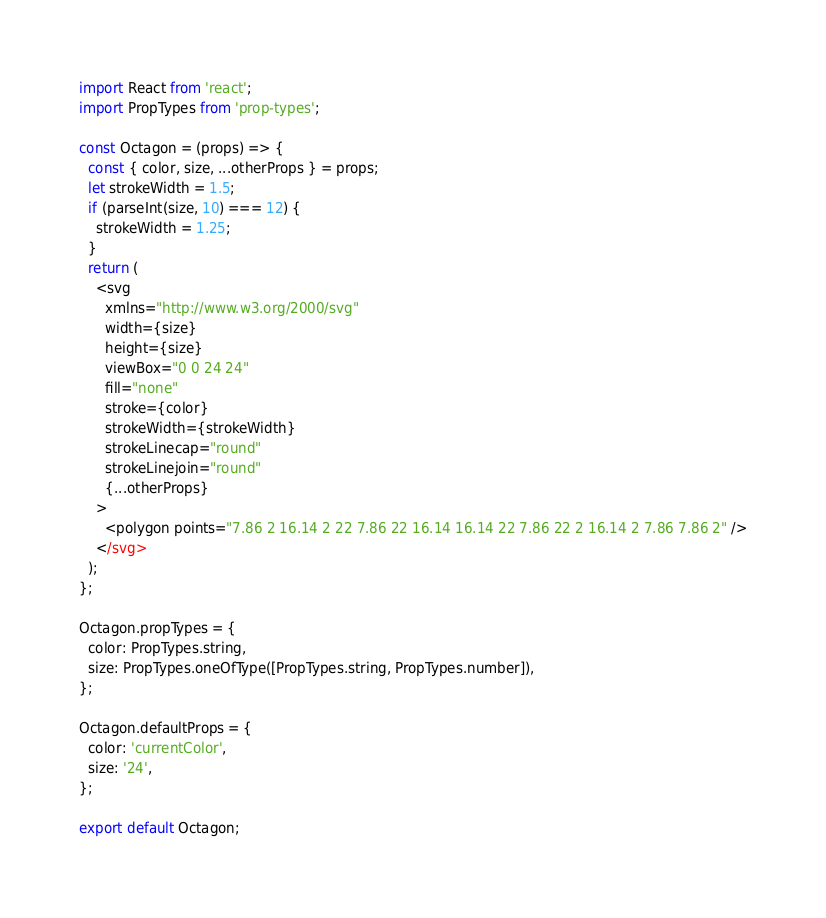Convert code to text. <code><loc_0><loc_0><loc_500><loc_500><_JavaScript_>import React from 'react';
import PropTypes from 'prop-types';

const Octagon = (props) => {
  const { color, size, ...otherProps } = props;
  let strokeWidth = 1.5;
  if (parseInt(size, 10) === 12) {
    strokeWidth = 1.25;
  }
  return (
    <svg
      xmlns="http://www.w3.org/2000/svg"
      width={size}
      height={size}
      viewBox="0 0 24 24"
      fill="none"
      stroke={color}
      strokeWidth={strokeWidth}
      strokeLinecap="round"
      strokeLinejoin="round"
      {...otherProps}
    >
      <polygon points="7.86 2 16.14 2 22 7.86 22 16.14 16.14 22 7.86 22 2 16.14 2 7.86 7.86 2" />
    </svg>
  );
};

Octagon.propTypes = {
  color: PropTypes.string,
  size: PropTypes.oneOfType([PropTypes.string, PropTypes.number]),
};

Octagon.defaultProps = {
  color: 'currentColor',
  size: '24',
};

export default Octagon;
</code> 